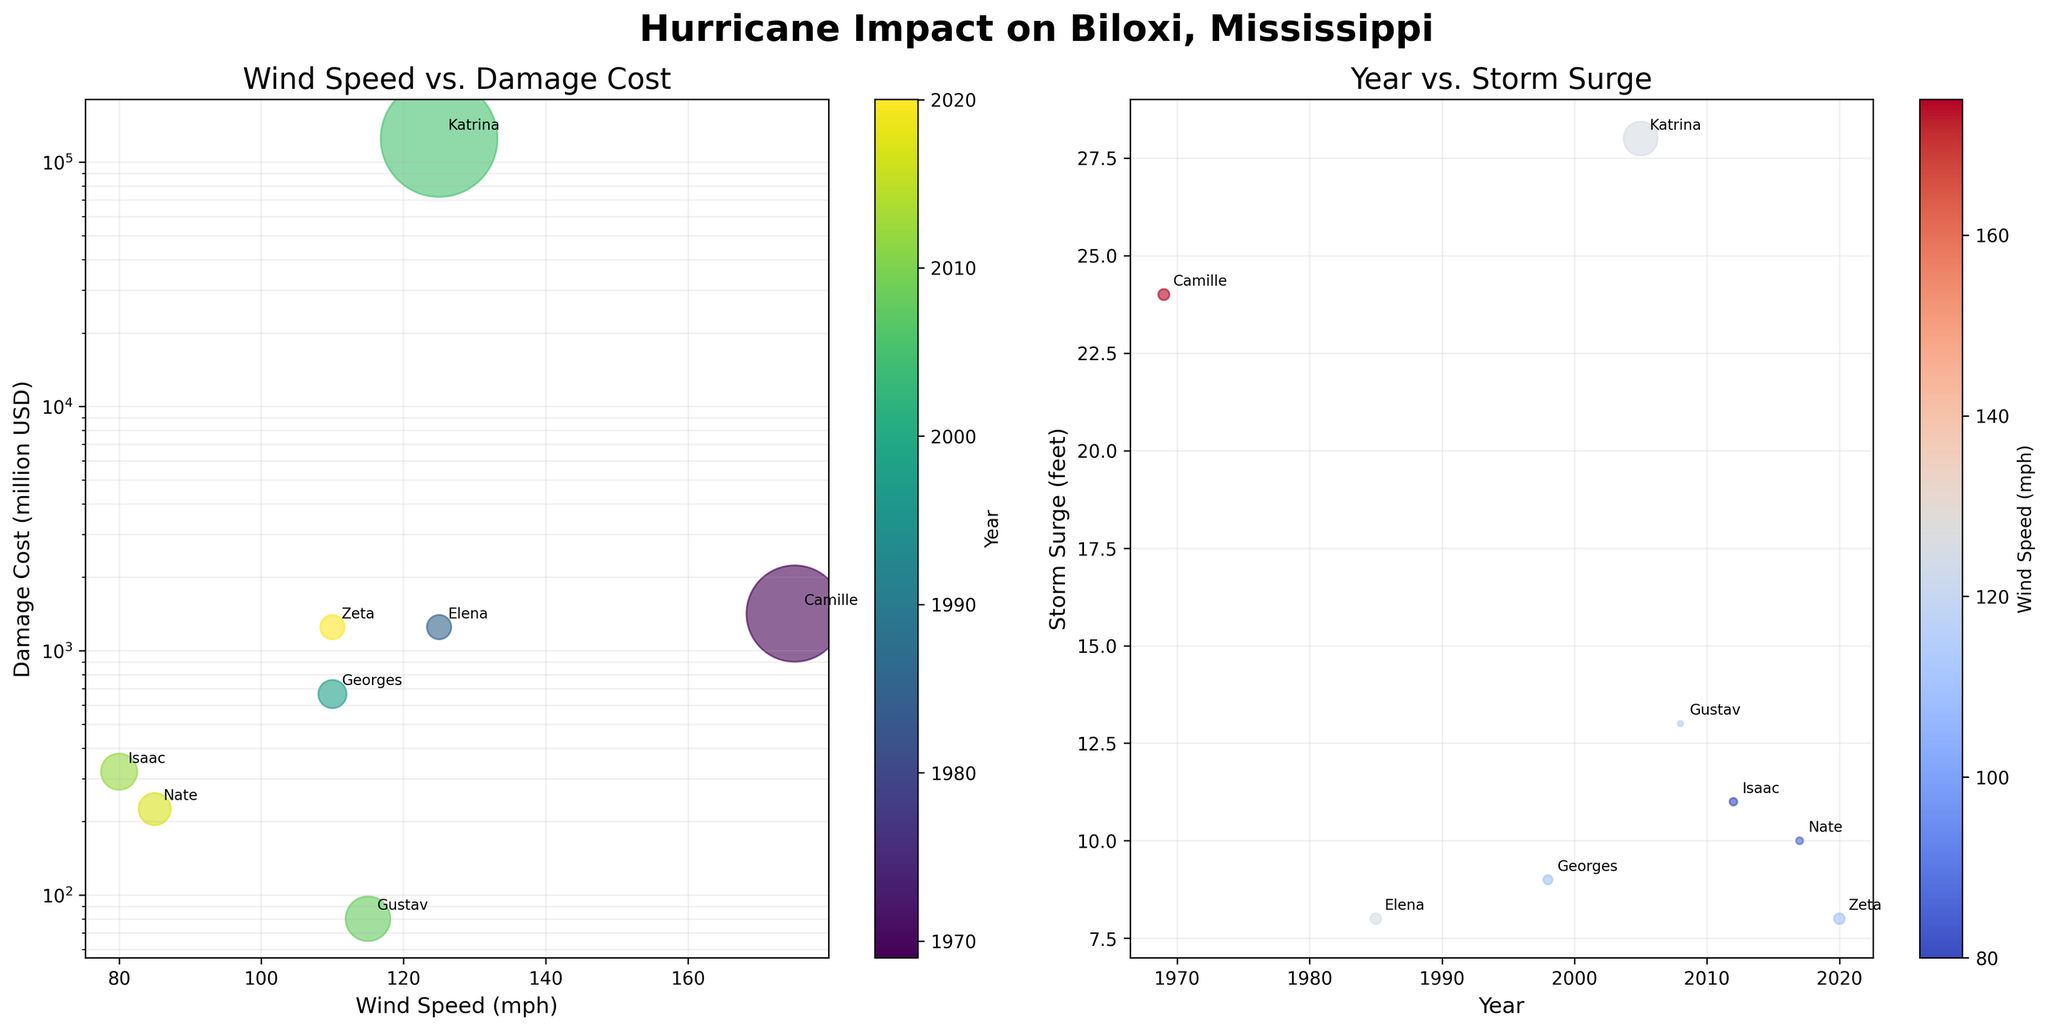What is the title of the figure? The title is usually located at the top of the figure. In this case, it reads 'Hurricane Impact on Biloxi, Mississippi'.
Answer: 'Hurricane Impact on Biloxi, Mississippi' What is the y-axis label of the first bubble chart? Labels for axes are typically found beside the axis lines. The first bubble chart has its y-axis labeled as 'Damage Cost (million USD)'.
Answer: 'Damage Cost (million USD)' What do the colors represent on the first bubble chart? The color legend or color bar next to the chart provides this information. The first bubble chart has a color bar labeled 'Year', indicating that colors represent different years.
Answer: Year In which year did Biloxi experience the highest storm surge according to the second bubble chart? By looking at the height of the bubbles in the second chart along the y-axis, the maximum storm surge can be identified. The highest storm surge (28 feet) is annotated as 'Katrina' which occurred in 2005.
Answer: 2005 Compare the storm surges between Hurricanes Camille and Katrina. By checking the y-axis positions of 'Camille' (1969) and 'Katrina' (2005) in the second bubble chart, Katrina has a higher storm surge (28 feet) compared to Camille (24 feet).
Answer: Katrina has a higher storm surge Which hurricane caused the highest damage cost? Looking at the first bubble chart, the bubble highest on the y-axis indicates the highest damage cost. 'Katrina' has the highest damage cost with 125000 million USD.
Answer: Katrina Which hurricane had the highest wind speed but caused comparatively low damage costs? By finding the highest point on the x-axis of the first bubble chart and checking its y-axis position, 'Camille' (1969) with 175 mph wind speed and relatively lower damage cost than Katrina is the answer.
Answer: Camille How does the storm surge for Hurricane Nate compare to Hurricane Isaac? By comparing the y-axis values for 'Nate' (2017) and 'Isaac' (2012) in the second bubble chart, Nate has a storm surge of 10 feet while Isaac has 11 feet.
Answer: Isaac has a higher storm surge What trend do you observe in storm surge heights over the years in the second bubble chart? By looking at the trend of bubble heights along the x-axis, heightened storm surges become more common in recent years (especially post-2005).
Answer: Storm surges tend to increase in height over the years Identify the hurricane with the lowest wind speed and its corresponding damage cost. In the first bubble chart, the leftmost bubble indicates the lowest wind speed. 'Isaac' (2012) has the lowest wind speed of 80 mph with a damage cost of 320 million USD.
Answer: Isaac, 320 million USD 